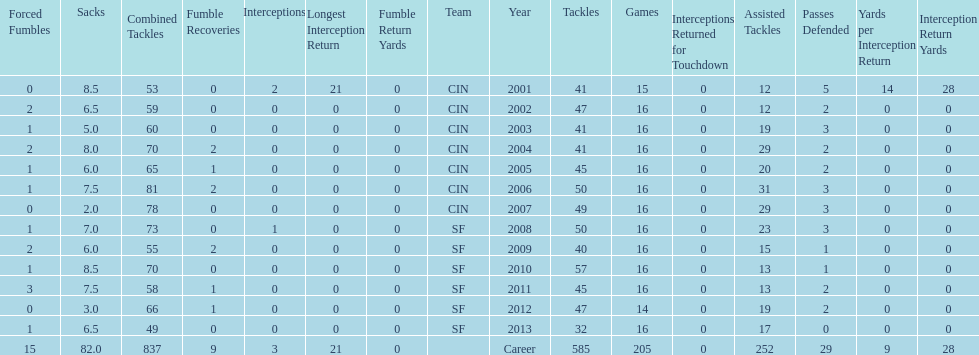How many seasons had combined tackles of 70 or more? 5. 